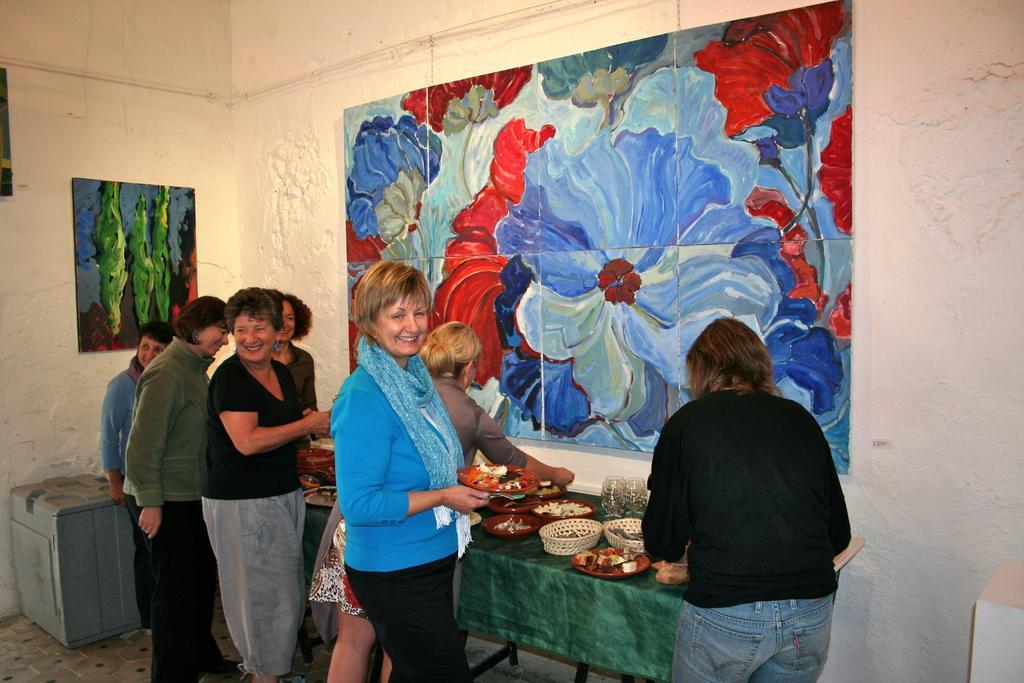Describe this image in one or two sentences. In this image there are paintings on the wall, in front of that there is a table with so many varieties of food where group of people are standing. 